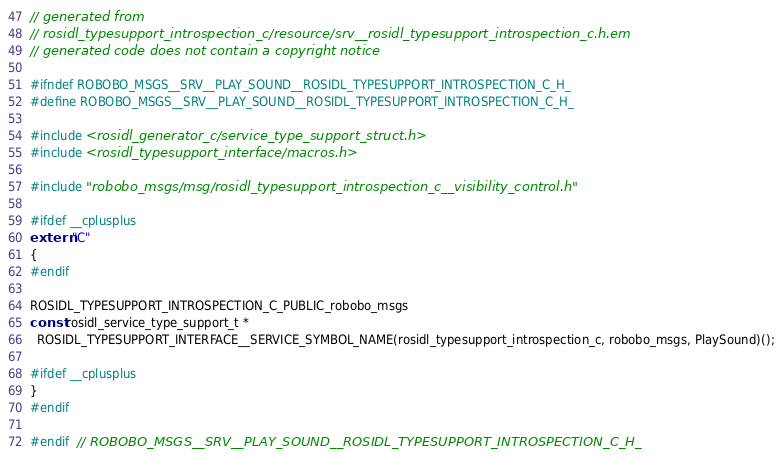Convert code to text. <code><loc_0><loc_0><loc_500><loc_500><_C_>// generated from
// rosidl_typesupport_introspection_c/resource/srv__rosidl_typesupport_introspection_c.h.em
// generated code does not contain a copyright notice

#ifndef ROBOBO_MSGS__SRV__PLAY_SOUND__ROSIDL_TYPESUPPORT_INTROSPECTION_C_H_
#define ROBOBO_MSGS__SRV__PLAY_SOUND__ROSIDL_TYPESUPPORT_INTROSPECTION_C_H_

#include <rosidl_generator_c/service_type_support_struct.h>
#include <rosidl_typesupport_interface/macros.h>

#include "robobo_msgs/msg/rosidl_typesupport_introspection_c__visibility_control.h"

#ifdef __cplusplus
extern "C"
{
#endif

ROSIDL_TYPESUPPORT_INTROSPECTION_C_PUBLIC_robobo_msgs
const rosidl_service_type_support_t *
  ROSIDL_TYPESUPPORT_INTERFACE__SERVICE_SYMBOL_NAME(rosidl_typesupport_introspection_c, robobo_msgs, PlaySound)();

#ifdef __cplusplus
}
#endif

#endif  // ROBOBO_MSGS__SRV__PLAY_SOUND__ROSIDL_TYPESUPPORT_INTROSPECTION_C_H_
</code> 